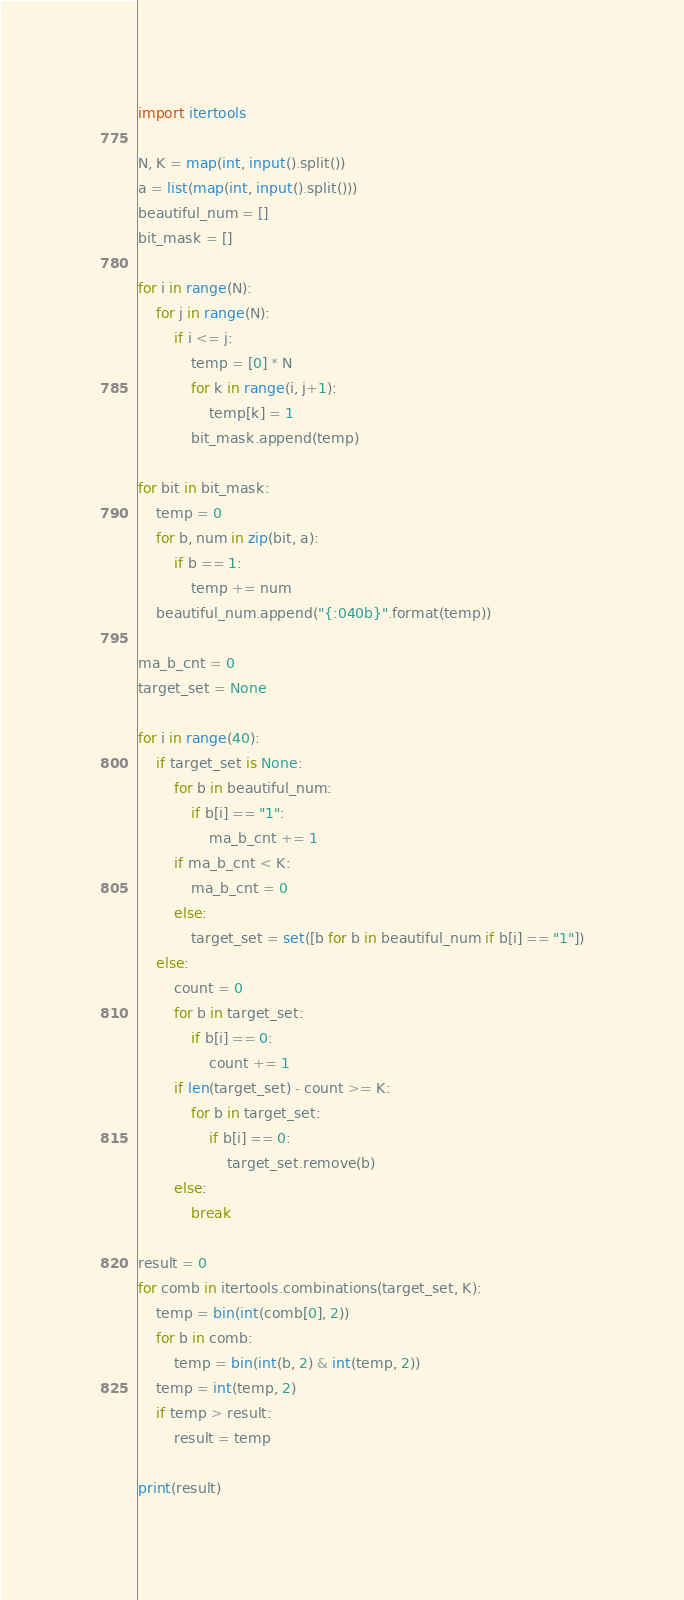Convert code to text. <code><loc_0><loc_0><loc_500><loc_500><_Python_>import itertools

N, K = map(int, input().split())
a = list(map(int, input().split()))
beautiful_num = []
bit_mask = []

for i in range(N):
    for j in range(N):
        if i <= j:
            temp = [0] * N
            for k in range(i, j+1):
                temp[k] = 1
            bit_mask.append(temp)

for bit in bit_mask:
    temp = 0
    for b, num in zip(bit, a):
        if b == 1:
            temp += num
    beautiful_num.append("{:040b}".format(temp))

ma_b_cnt = 0
target_set = None

for i in range(40):
    if target_set is None:
        for b in beautiful_num:
            if b[i] == "1":
                ma_b_cnt += 1
        if ma_b_cnt < K:
            ma_b_cnt = 0
        else:
            target_set = set([b for b in beautiful_num if b[i] == "1"])
    else:
        count = 0
        for b in target_set:
            if b[i] == 0:
                count += 1
        if len(target_set) - count >= K:
            for b in target_set:
                if b[i] == 0:
                    target_set.remove(b)
        else:
            break

result = 0
for comb in itertools.combinations(target_set, K):
    temp = bin(int(comb[0], 2))
    for b in comb:
        temp = bin(int(b, 2) & int(temp, 2))
    temp = int(temp, 2)
    if temp > result:
        result = temp

print(result)</code> 